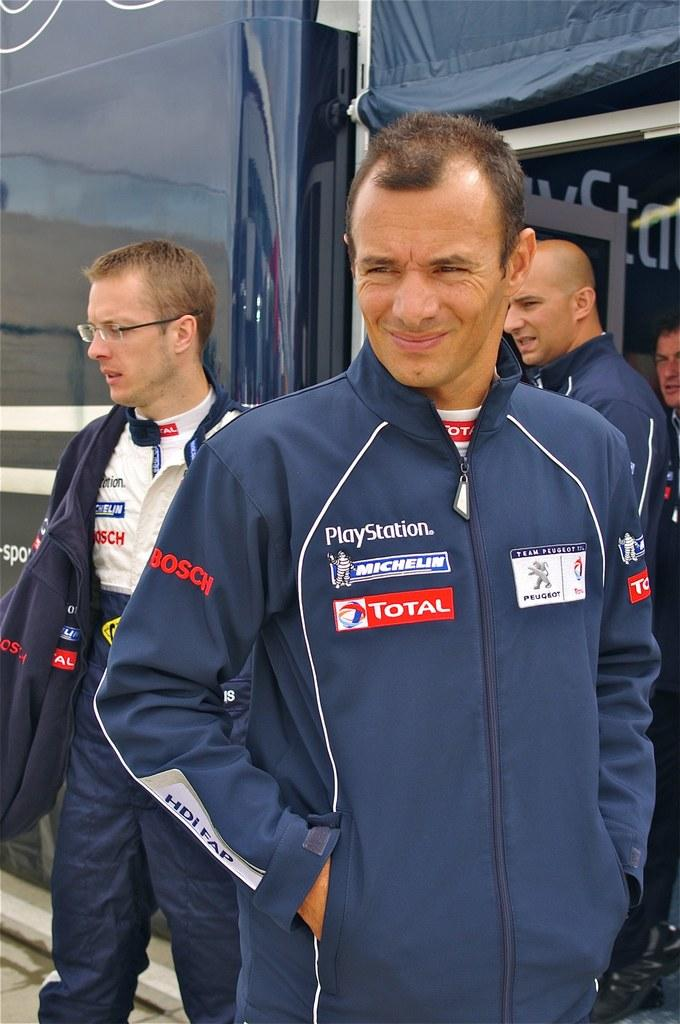Provide a one-sentence caption for the provided image. A group of people in car racing coveralls that says Playstation 3 on them. 